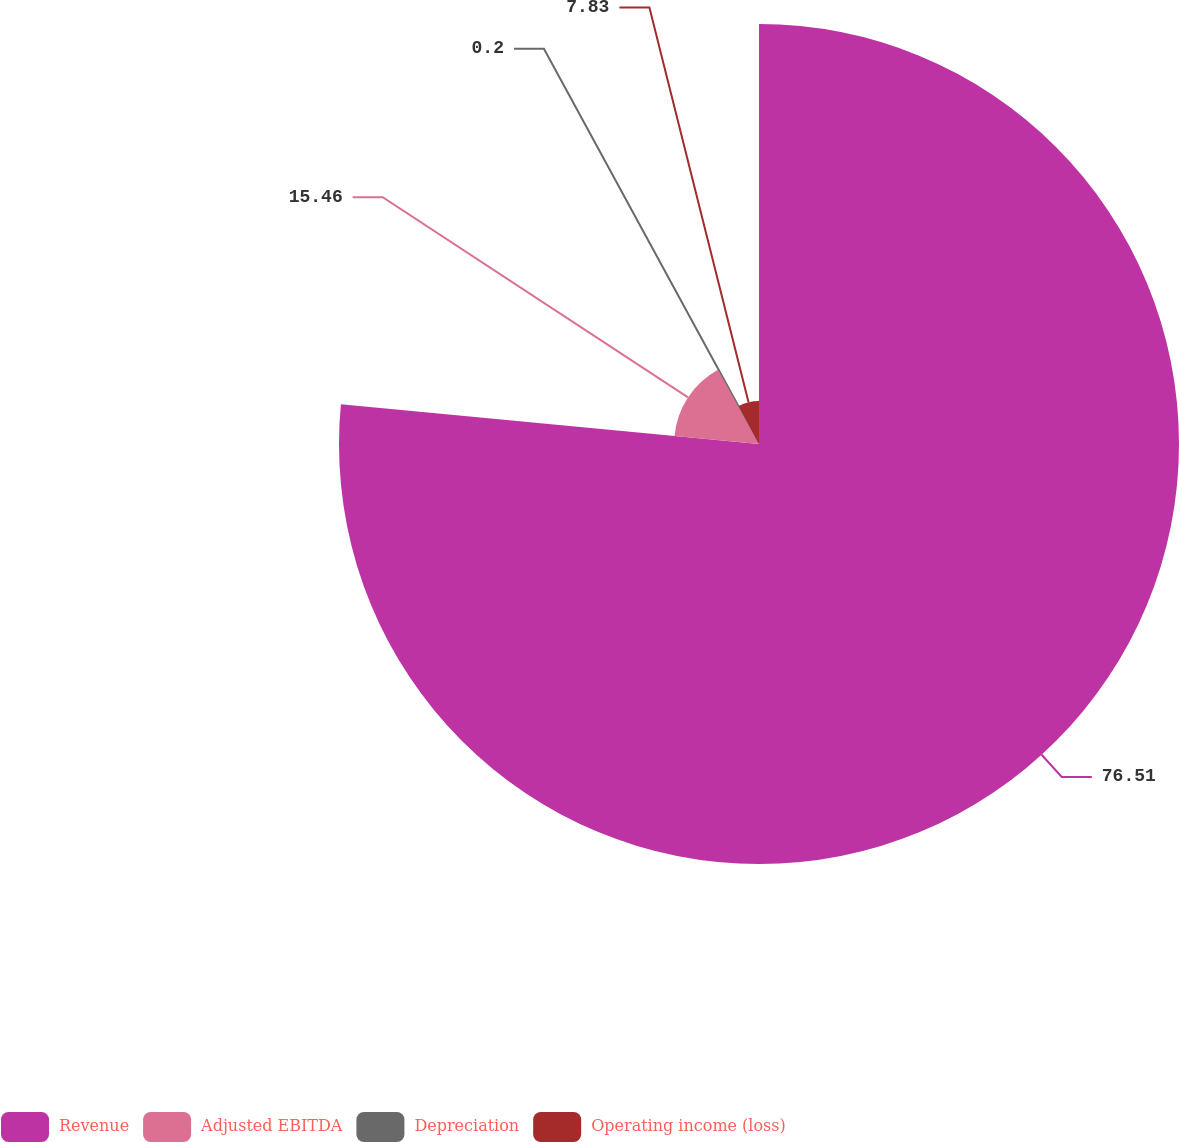Convert chart. <chart><loc_0><loc_0><loc_500><loc_500><pie_chart><fcel>Revenue<fcel>Adjusted EBITDA<fcel>Depreciation<fcel>Operating income (loss)<nl><fcel>76.5%<fcel>15.46%<fcel>0.2%<fcel>7.83%<nl></chart> 